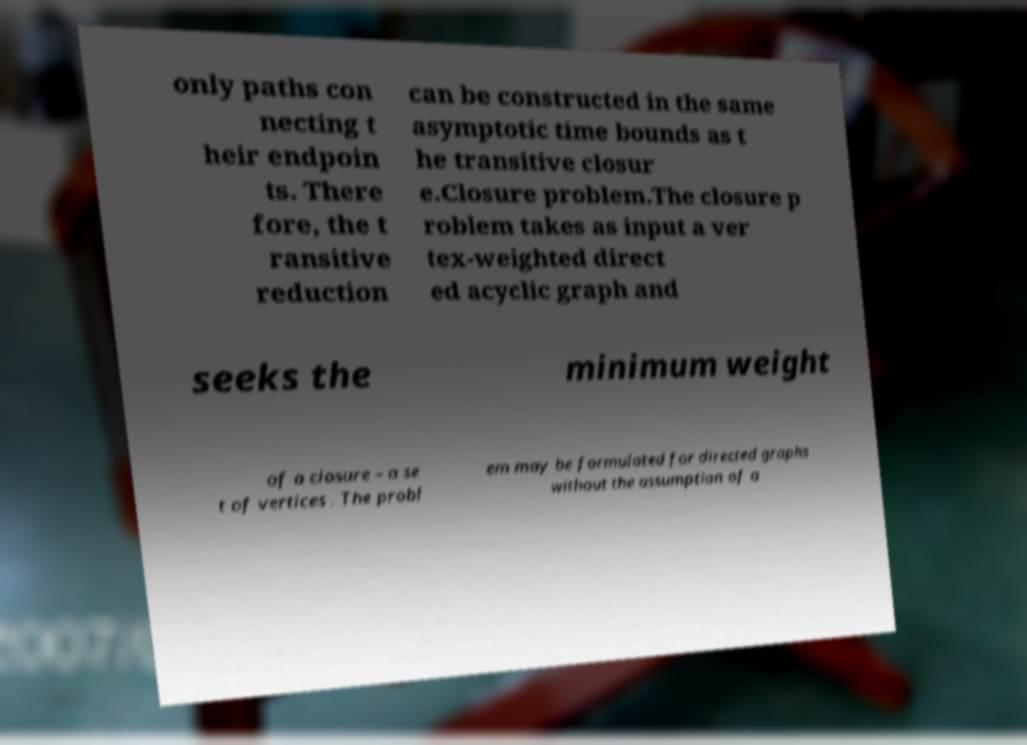Could you assist in decoding the text presented in this image and type it out clearly? only paths con necting t heir endpoin ts. There fore, the t ransitive reduction can be constructed in the same asymptotic time bounds as t he transitive closur e.Closure problem.The closure p roblem takes as input a ver tex-weighted direct ed acyclic graph and seeks the minimum weight of a closure – a se t of vertices . The probl em may be formulated for directed graphs without the assumption of a 